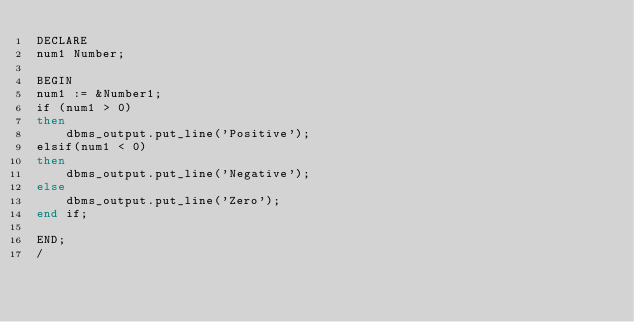Convert code to text. <code><loc_0><loc_0><loc_500><loc_500><_SQL_>DECLARE
num1 Number;

BEGIN
num1 := &Number1;
if (num1 > 0) 
then
	dbms_output.put_line('Positive');
elsif(num1 < 0)
then
	dbms_output.put_line('Negative');
else
	dbms_output.put_line('Zero');
end if;

END;
/
</code> 